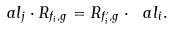<formula> <loc_0><loc_0><loc_500><loc_500>\ a l _ { j } \cdot R _ { f _ { i } , g } = R _ { f ^ { \prime } _ { i } , g } \cdot \ a l _ { i } .</formula> 